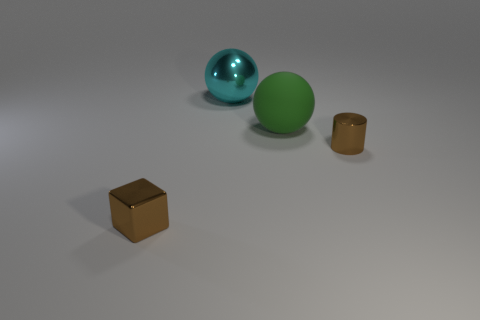Add 1 tiny cylinders. How many objects exist? 5 Subtract 1 balls. How many balls are left? 1 Add 2 big cyan spheres. How many big cyan spheres are left? 3 Add 4 big purple things. How many big purple things exist? 4 Subtract 0 gray cylinders. How many objects are left? 4 Subtract all cylinders. How many objects are left? 3 Subtract all blue spheres. Subtract all red cylinders. How many spheres are left? 2 Subtract all green blocks. How many gray cylinders are left? 0 Subtract all large blue matte cylinders. Subtract all large rubber balls. How many objects are left? 3 